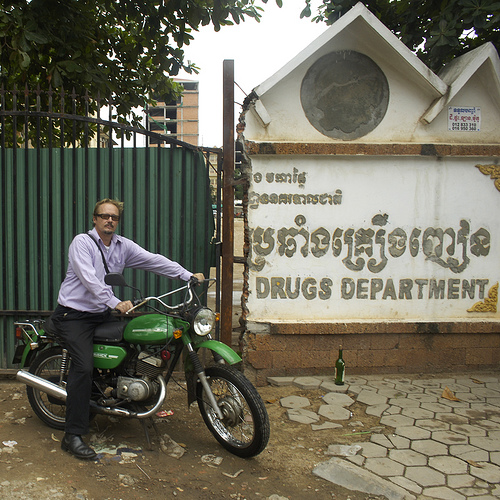Please extract the text content from this image. DRUGS DEPARTMENT 